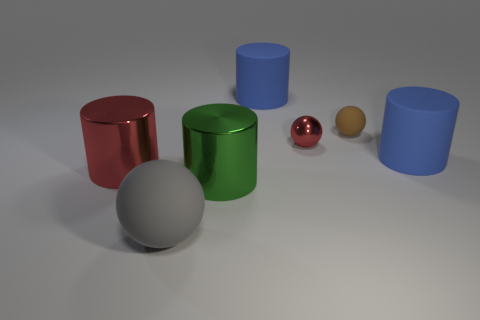What number of balls have the same size as the brown object?
Ensure brevity in your answer.  1. Is the number of red metal cylinders that are behind the brown object greater than the number of rubber objects on the right side of the gray thing?
Your response must be concise. No. There is a big metallic cylinder right of the big matte object that is in front of the red cylinder; what is its color?
Give a very brief answer. Green. Are the brown ball and the gray thing made of the same material?
Your answer should be compact. Yes. Is there a large metallic object of the same shape as the brown rubber object?
Offer a very short reply. No. There is a large shiny thing on the left side of the gray matte thing; is it the same color as the tiny shiny object?
Offer a terse response. Yes. Does the rubber sphere behind the gray thing have the same size as the blue cylinder that is on the right side of the small red object?
Provide a succinct answer. No. There is a brown object that is made of the same material as the big gray sphere; what size is it?
Offer a terse response. Small. What number of balls are both right of the red ball and on the left side of the small matte object?
Provide a succinct answer. 0. How many things are either small red metallic balls or things that are on the right side of the big rubber sphere?
Make the answer very short. 5. 